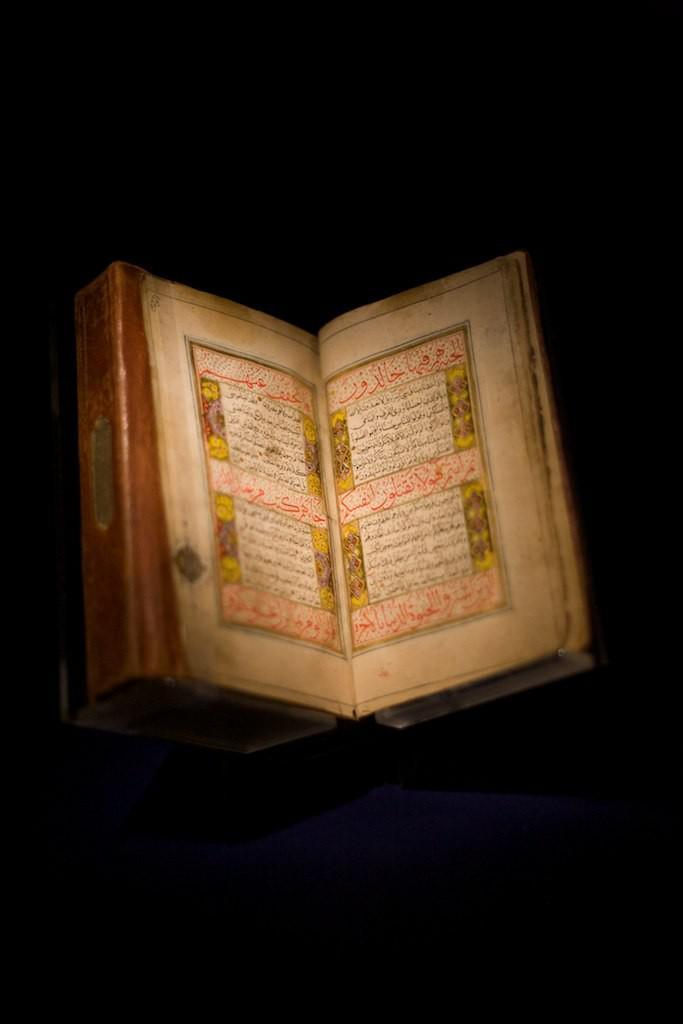In one or two sentences, can you explain what this image depicts? In this image we can see a book with text. The background of the image is dark. 